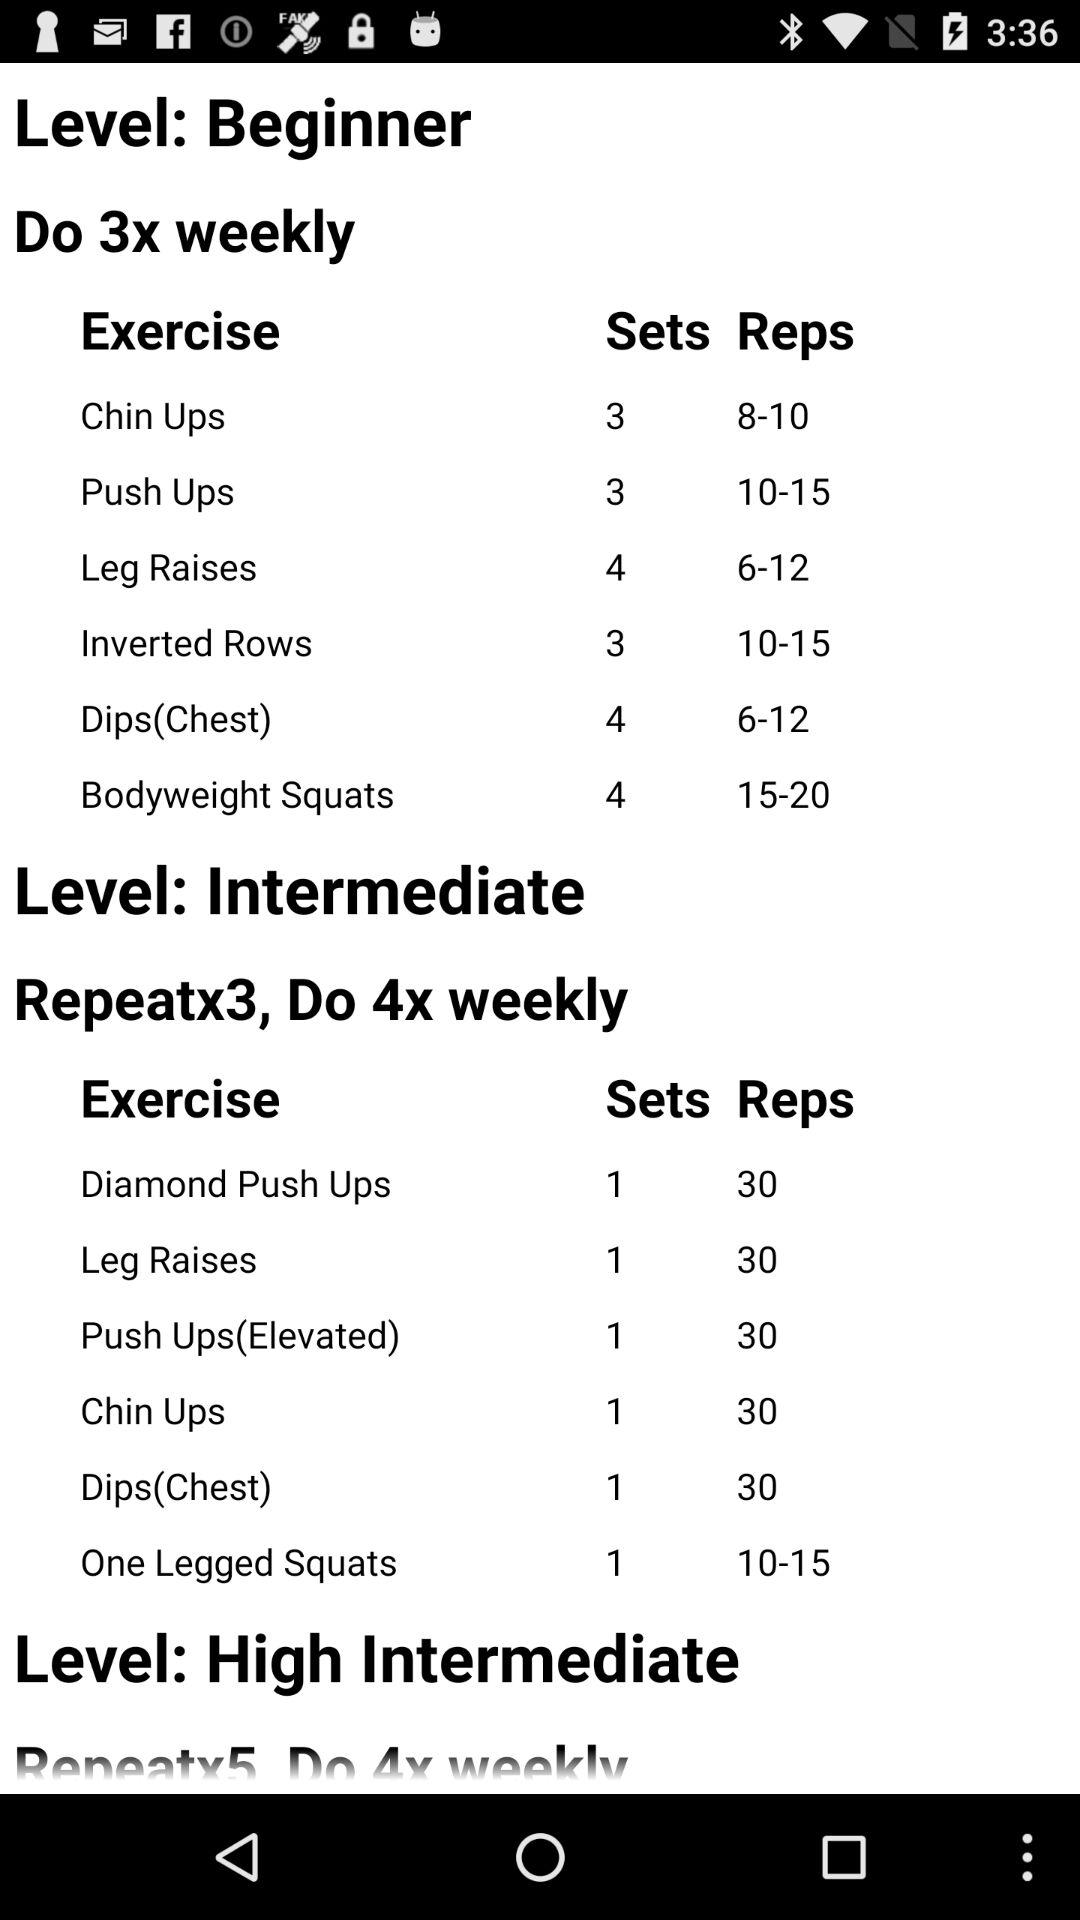How many times should we exercise in a week at the beginner level? You should exercise three times a week at the beginner level. 